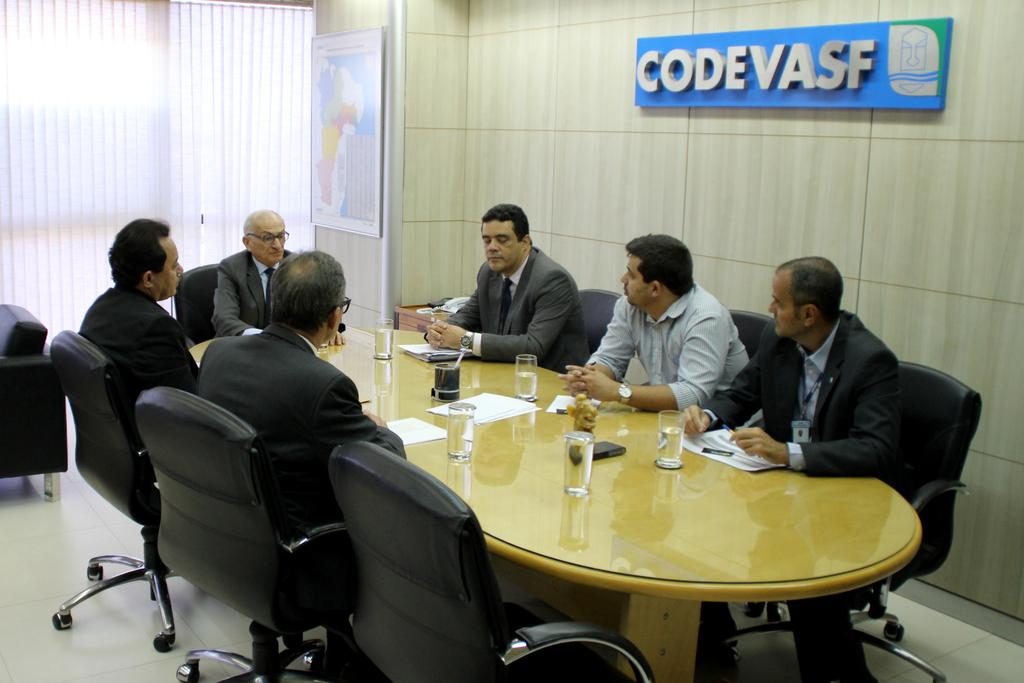<image>
Summarize the visual content of the image. A group of men are at a board meeting table and a sign above them Codevasf. 